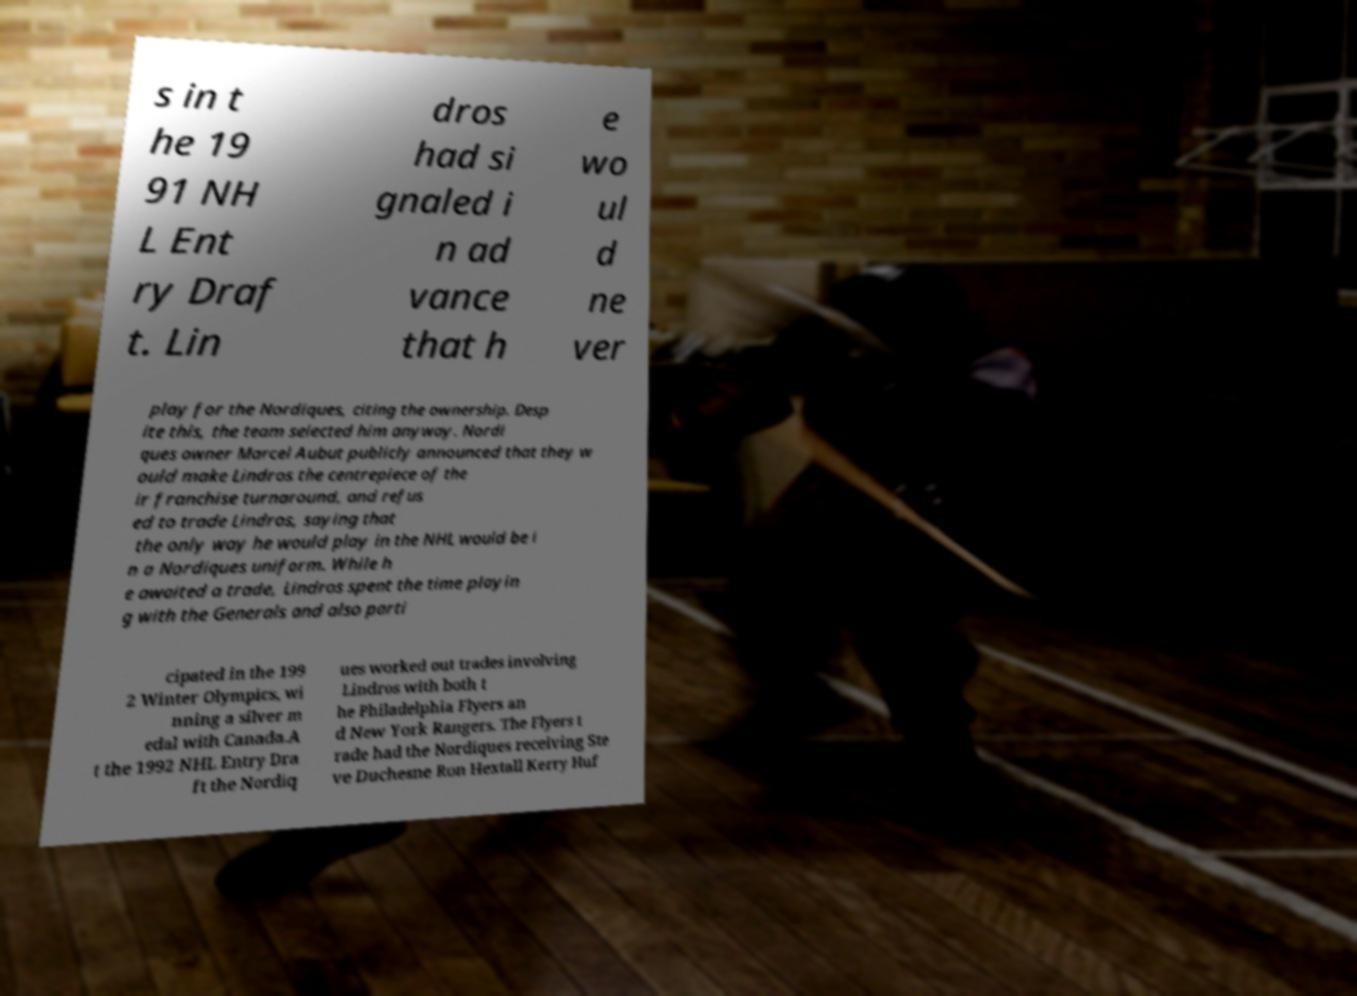Could you assist in decoding the text presented in this image and type it out clearly? s in t he 19 91 NH L Ent ry Draf t. Lin dros had si gnaled i n ad vance that h e wo ul d ne ver play for the Nordiques, citing the ownership. Desp ite this, the team selected him anyway. Nordi ques owner Marcel Aubut publicly announced that they w ould make Lindros the centrepiece of the ir franchise turnaround, and refus ed to trade Lindros, saying that the only way he would play in the NHL would be i n a Nordiques uniform. While h e awaited a trade, Lindros spent the time playin g with the Generals and also parti cipated in the 199 2 Winter Olympics, wi nning a silver m edal with Canada.A t the 1992 NHL Entry Dra ft the Nordiq ues worked out trades involving Lindros with both t he Philadelphia Flyers an d New York Rangers. The Flyers t rade had the Nordiques receiving Ste ve Duchesne Ron Hextall Kerry Huf 